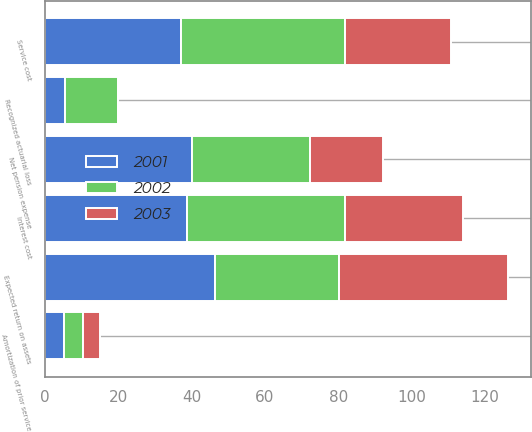<chart> <loc_0><loc_0><loc_500><loc_500><stacked_bar_chart><ecel><fcel>Service cost<fcel>Interest cost<fcel>Expected return on assets<fcel>Amortization of prior service<fcel>Recognized actuarial loss<fcel>Net pension expense<nl><fcel>2003<fcel>29<fcel>32.3<fcel>46<fcel>4.6<fcel>0.1<fcel>20<nl><fcel>2001<fcel>37.2<fcel>38.6<fcel>46.4<fcel>5.2<fcel>5.4<fcel>40<nl><fcel>2002<fcel>44.6<fcel>43.1<fcel>33.9<fcel>5.2<fcel>14.5<fcel>32.3<nl></chart> 